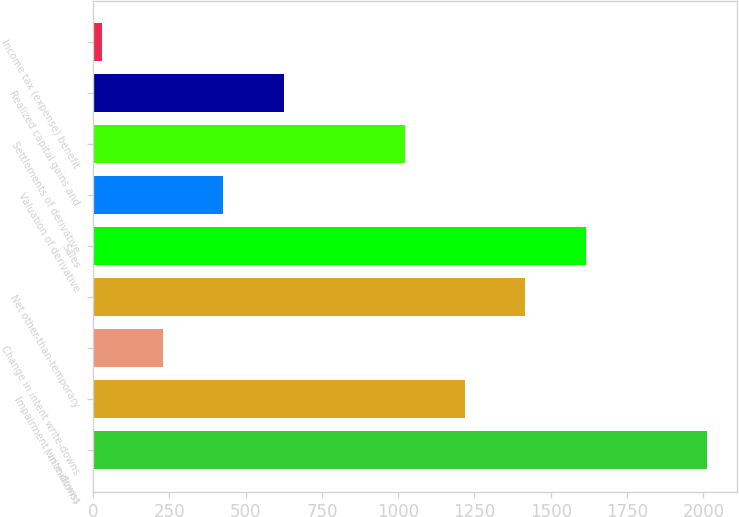Convert chart. <chart><loc_0><loc_0><loc_500><loc_500><bar_chart><fcel>( in millions)<fcel>Impairment write-downs<fcel>Change in intent write-downs<fcel>Net other-than-temporary<fcel>Sales<fcel>Valuation of derivative<fcel>Settlements of derivative<fcel>Realized capital gains and<fcel>Income tax (expense) benefit<nl><fcel>2011<fcel>1219<fcel>229<fcel>1417<fcel>1615<fcel>427<fcel>1021<fcel>625<fcel>31<nl></chart> 